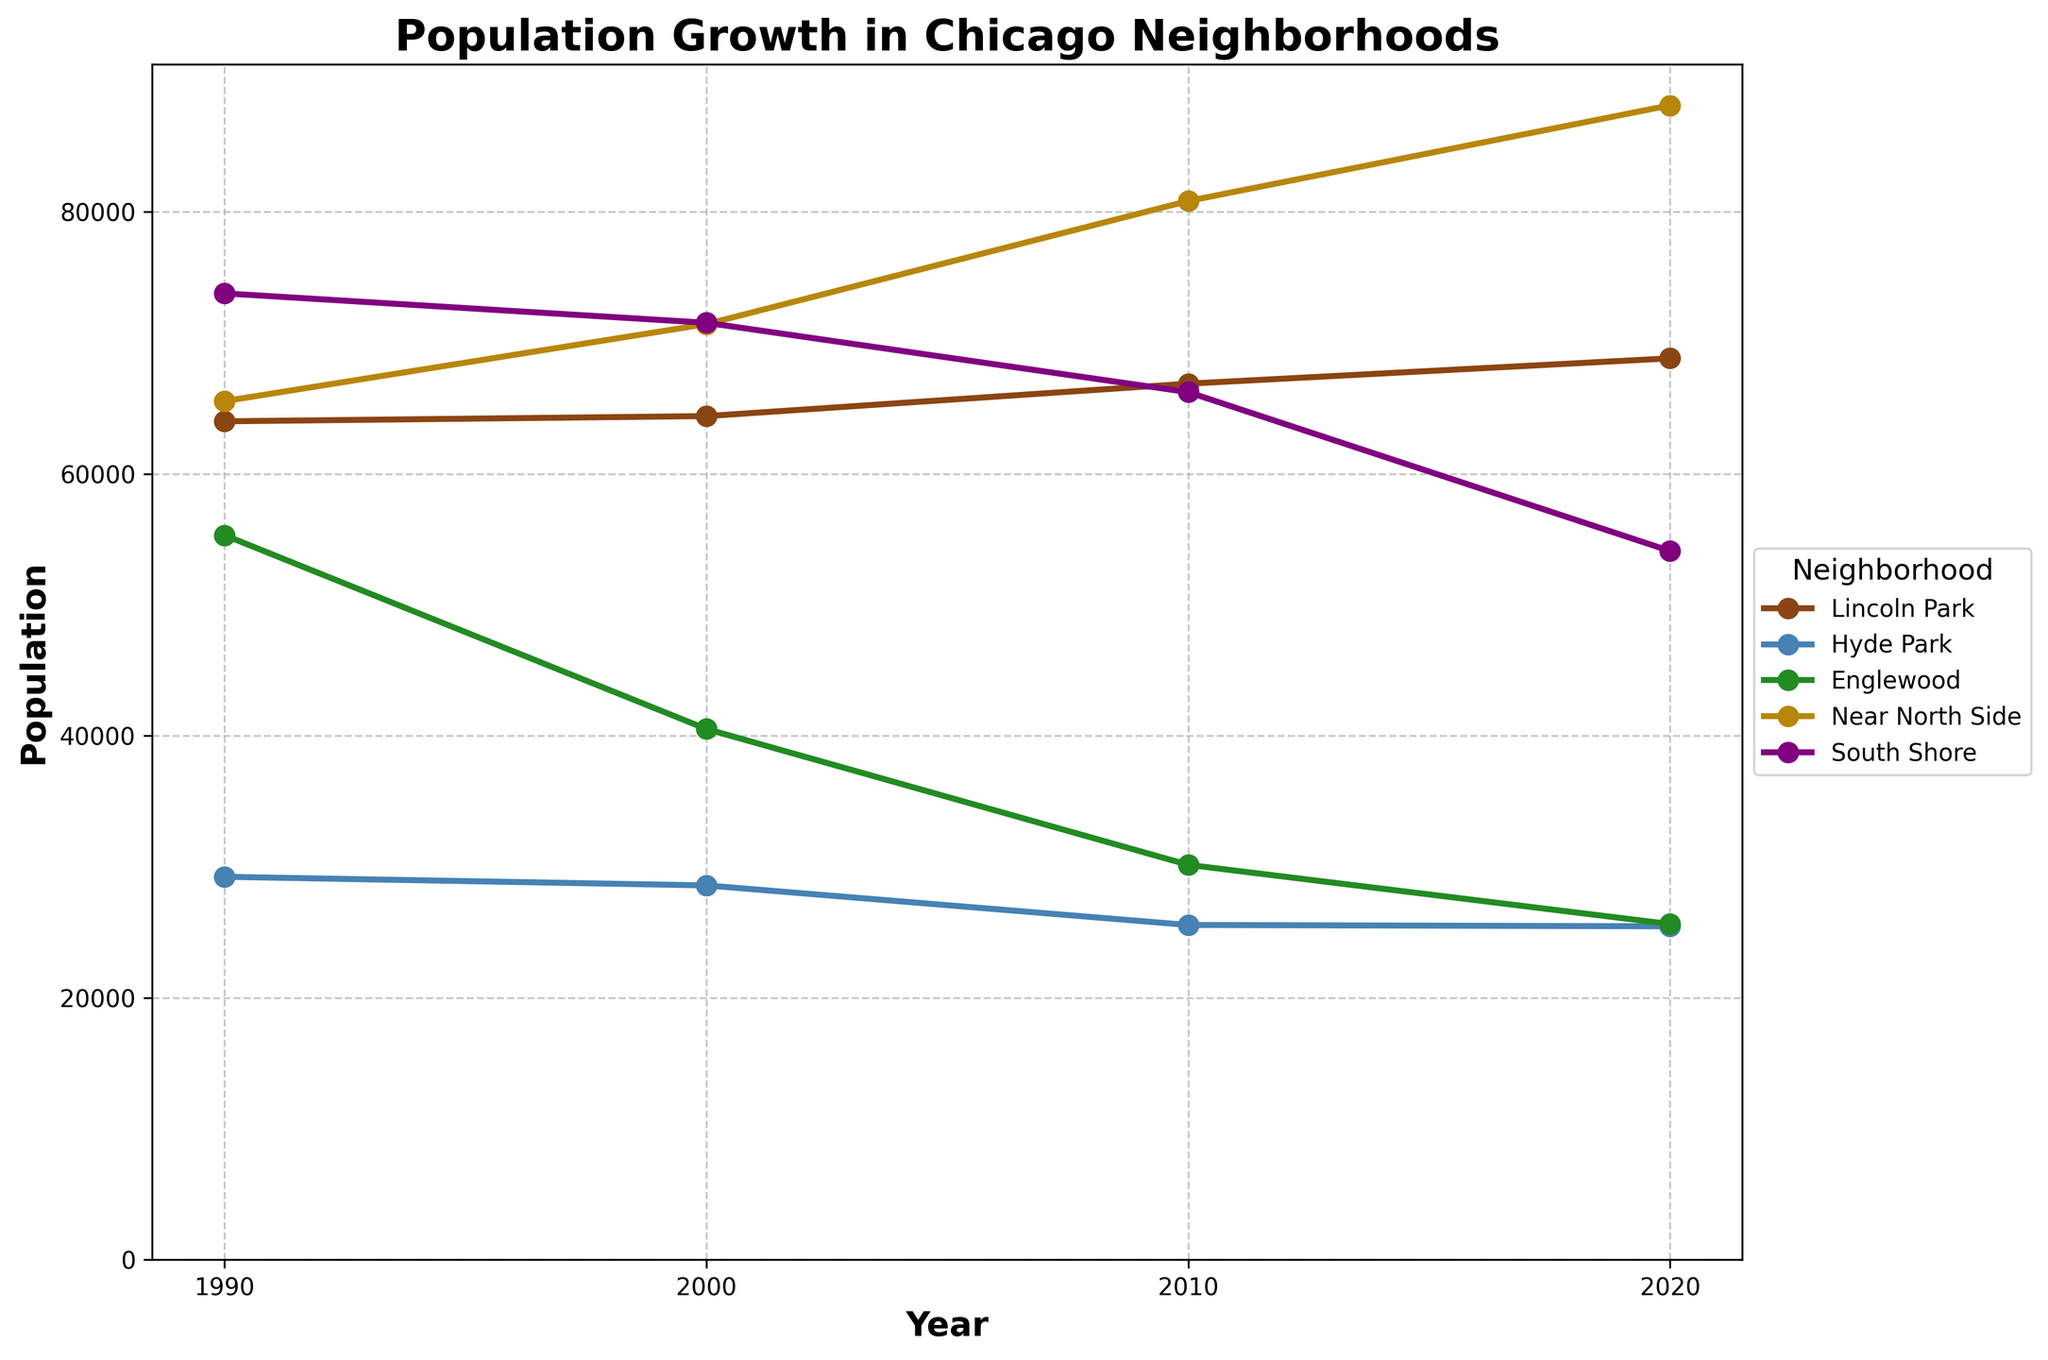What is the title of the plot? The title of the plot is written at the top center of the figure, it reads "Population Growth in Chicago Neighborhoods".
Answer: Population Growth in Chicago Neighborhoods What does the x-axis represent? The x-axis is labeled at the bottom of the figure and it represents the "Year".
Answer: Year Which neighborhood had the highest population in 2020? In the plot, each neighborhood is represented by a different colored line with markers at each year. For 2020, the Near North Side line is the highest point among other neighborhoods, indicating it had the highest population.
Answer: Near North Side How many neighborhoods are displayed in the plot? There are distinct lines in different colors representing different neighborhoods. Each line is labeled in the legend. There are five neighborhoods shown in the legend and plot.
Answer: Five Did the population of Englewood increase or decrease between 1990 and 2020? By comparing the position of the Englewood line at 1990 and 2020, we can see that the line decreases from 1990 to 2020, indicating a decrease in population.
Answer: Decrease Which neighborhood experienced the largest population growth between 1990 and 2020? To determine this, we need to compare the population points at 1990 and 2020 for each neighborhood. The Near North Side shows the highest positive difference from its 1990 population to its 2020 population.
Answer: Near North Side What was the population of the South Shore in 2000? In the plot, find the year 2000 on the x-axis and look at the data point for South Shore, the y-axis value at that point indicates the population.
Answer: 71,535 How did the population of Lincoln Park change from 1990 to 2000? The Lincoln Park line shows an increase in population from the 1990 marker to the 2000 marker. We compare both y-axis points: 64,010 in 1990 to 64,410 in 2000 for a slight increase.
Answer: Increased Which two neighborhoods had the closest population values in 2010? Examine the 2010 data points for each neighborhood and compare their values. Hyde Park and Englewood have similar values (25,556 and 30,147).
Answer: Hyde Park and Englewood Has any neighborhood shown a continuous decline in population over the years? Looking at the plot trends from 1990 to 2020, Hyde Park shows a consistent downward trend in its population line, indicating a continuous decline.
Answer: Hyde Park 